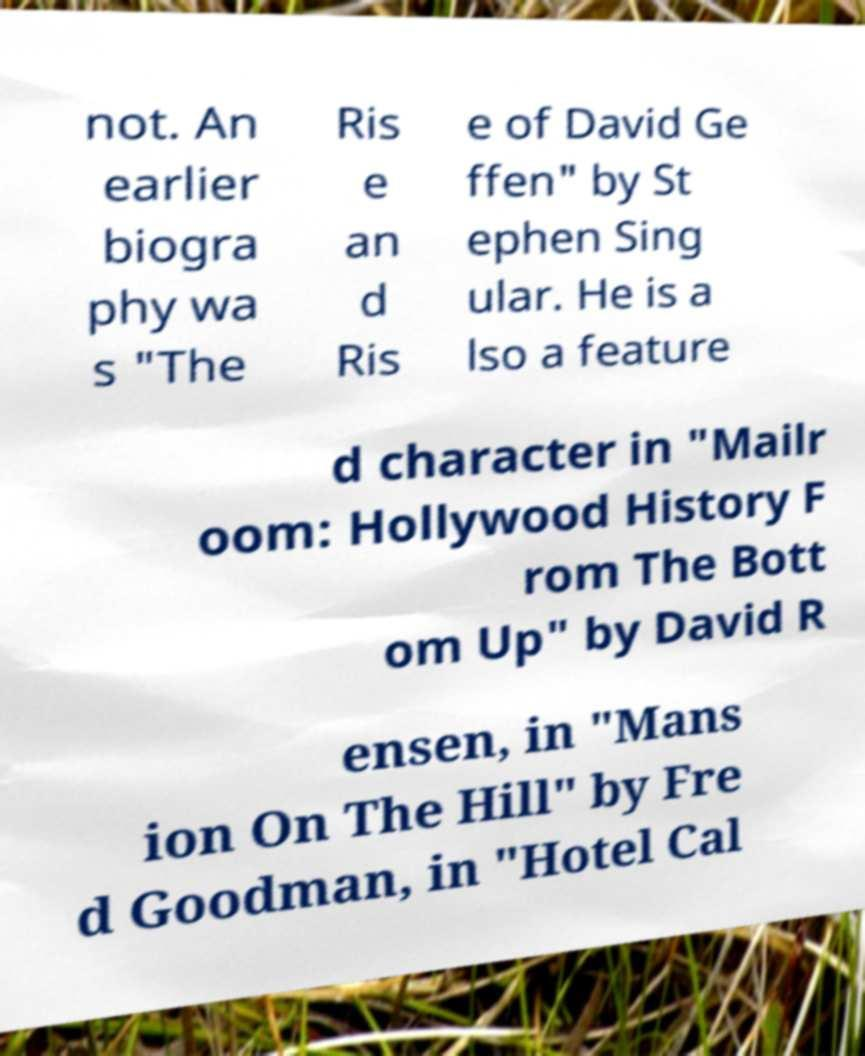Could you extract and type out the text from this image? not. An earlier biogra phy wa s "The Ris e an d Ris e of David Ge ffen" by St ephen Sing ular. He is a lso a feature d character in "Mailr oom: Hollywood History F rom The Bott om Up" by David R ensen, in "Mans ion On The Hill" by Fre d Goodman, in "Hotel Cal 